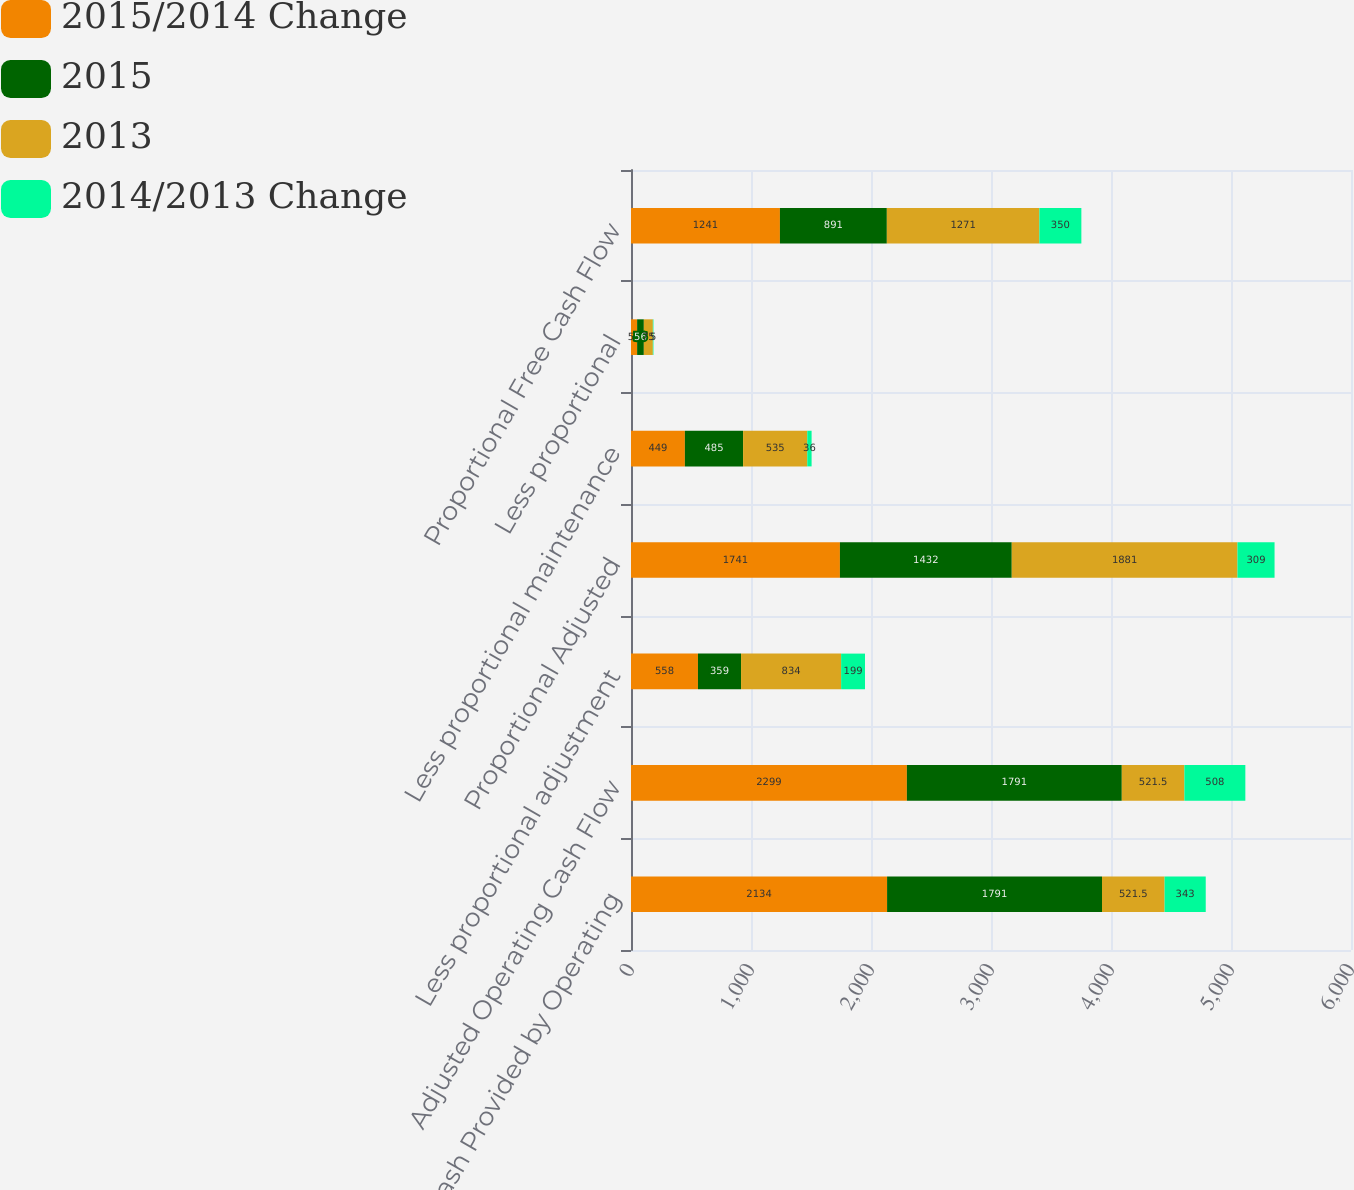Convert chart. <chart><loc_0><loc_0><loc_500><loc_500><stacked_bar_chart><ecel><fcel>Net Cash Provided by Operating<fcel>Adjusted Operating Cash Flow<fcel>Less proportional adjustment<fcel>Proportional Adjusted<fcel>Less proportional maintenance<fcel>Less proportional<fcel>Proportional Free Cash Flow<nl><fcel>2015/2014 Change<fcel>2134<fcel>2299<fcel>558<fcel>1741<fcel>449<fcel>51<fcel>1241<nl><fcel>2015<fcel>1791<fcel>1791<fcel>359<fcel>1432<fcel>485<fcel>56<fcel>891<nl><fcel>2013<fcel>521.5<fcel>521.5<fcel>834<fcel>1881<fcel>535<fcel>75<fcel>1271<nl><fcel>2014/2013 Change<fcel>343<fcel>508<fcel>199<fcel>309<fcel>36<fcel>5<fcel>350<nl></chart> 